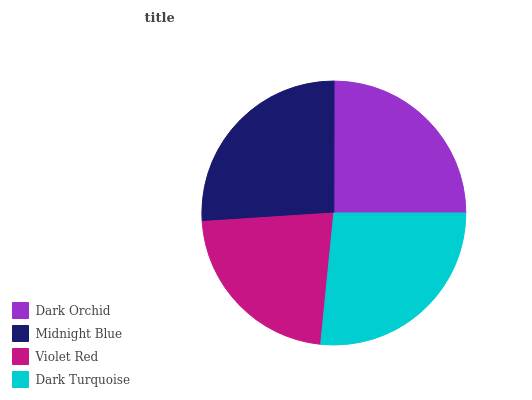Is Violet Red the minimum?
Answer yes or no. Yes. Is Dark Turquoise the maximum?
Answer yes or no. Yes. Is Midnight Blue the minimum?
Answer yes or no. No. Is Midnight Blue the maximum?
Answer yes or no. No. Is Midnight Blue greater than Dark Orchid?
Answer yes or no. Yes. Is Dark Orchid less than Midnight Blue?
Answer yes or no. Yes. Is Dark Orchid greater than Midnight Blue?
Answer yes or no. No. Is Midnight Blue less than Dark Orchid?
Answer yes or no. No. Is Midnight Blue the high median?
Answer yes or no. Yes. Is Dark Orchid the low median?
Answer yes or no. Yes. Is Dark Orchid the high median?
Answer yes or no. No. Is Midnight Blue the low median?
Answer yes or no. No. 